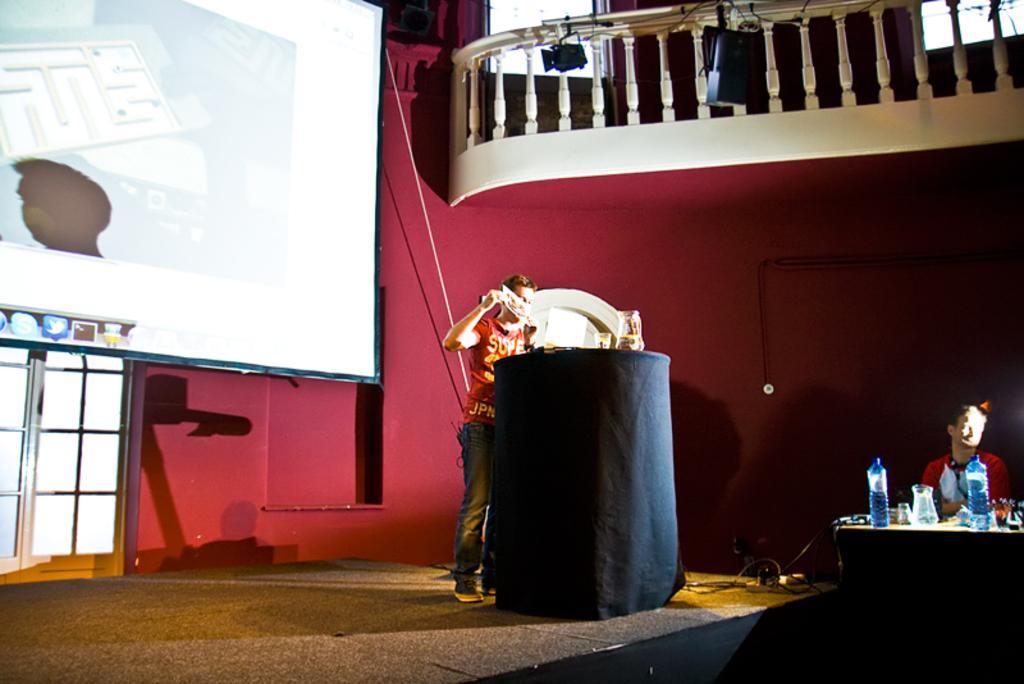Describe this image in one or two sentences. In this picture there is a man who is standing near to the speech desk. On the left I can see the projector screen which is placed near to the door. On the right there is a man who is sitting near to the table. On the table I can see the glass, water bottles, laptop, and cables. In the top right I can see the railing near to the windows. 